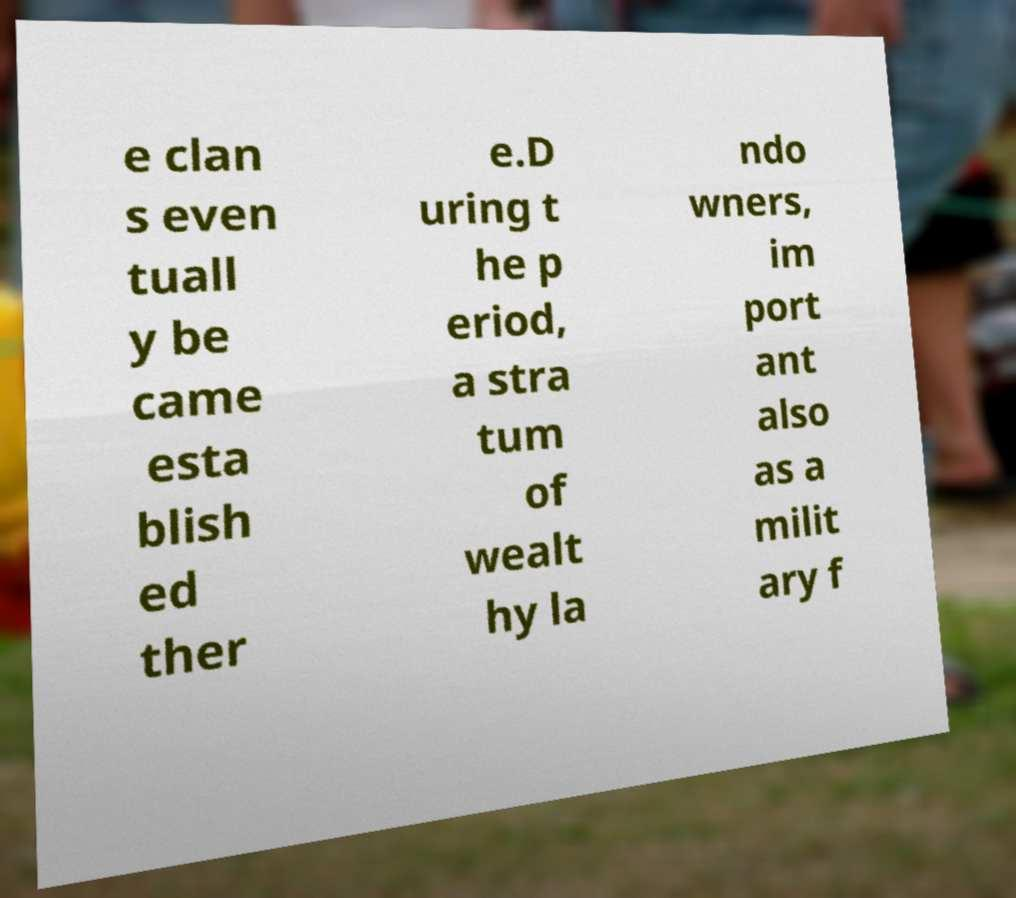Could you extract and type out the text from this image? e clan s even tuall y be came esta blish ed ther e.D uring t he p eriod, a stra tum of wealt hy la ndo wners, im port ant also as a milit ary f 